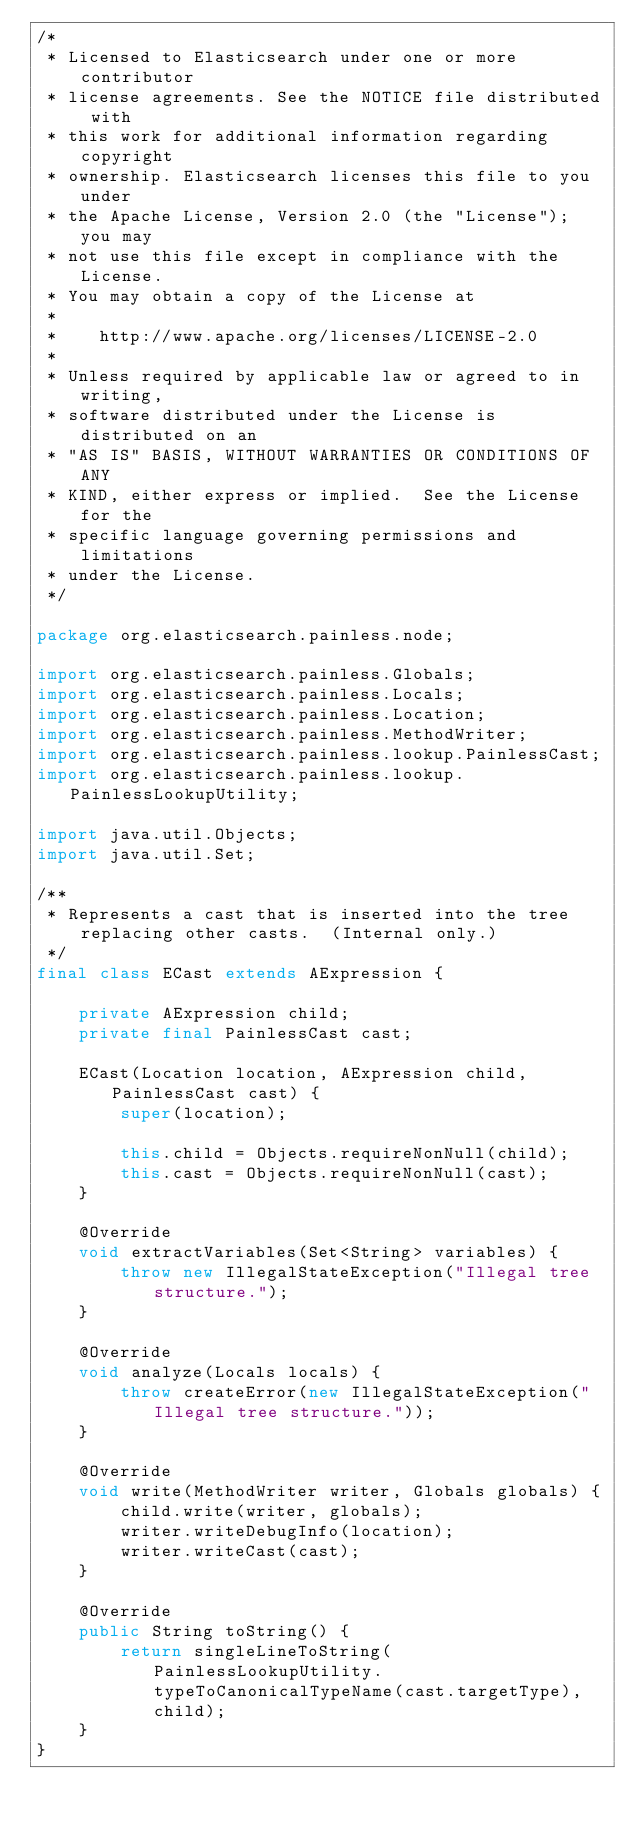Convert code to text. <code><loc_0><loc_0><loc_500><loc_500><_Java_>/*
 * Licensed to Elasticsearch under one or more contributor
 * license agreements. See the NOTICE file distributed with
 * this work for additional information regarding copyright
 * ownership. Elasticsearch licenses this file to you under
 * the Apache License, Version 2.0 (the "License"); you may
 * not use this file except in compliance with the License.
 * You may obtain a copy of the License at
 *
 *    http://www.apache.org/licenses/LICENSE-2.0
 *
 * Unless required by applicable law or agreed to in writing,
 * software distributed under the License is distributed on an
 * "AS IS" BASIS, WITHOUT WARRANTIES OR CONDITIONS OF ANY
 * KIND, either express or implied.  See the License for the
 * specific language governing permissions and limitations
 * under the License.
 */

package org.elasticsearch.painless.node;

import org.elasticsearch.painless.Globals;
import org.elasticsearch.painless.Locals;
import org.elasticsearch.painless.Location;
import org.elasticsearch.painless.MethodWriter;
import org.elasticsearch.painless.lookup.PainlessCast;
import org.elasticsearch.painless.lookup.PainlessLookupUtility;

import java.util.Objects;
import java.util.Set;

/**
 * Represents a cast that is inserted into the tree replacing other casts.  (Internal only.)
 */
final class ECast extends AExpression {

    private AExpression child;
    private final PainlessCast cast;

    ECast(Location location, AExpression child, PainlessCast cast) {
        super(location);

        this.child = Objects.requireNonNull(child);
        this.cast = Objects.requireNonNull(cast);
    }

    @Override
    void extractVariables(Set<String> variables) {
        throw new IllegalStateException("Illegal tree structure.");
    }

    @Override
    void analyze(Locals locals) {
        throw createError(new IllegalStateException("Illegal tree structure."));
    }

    @Override
    void write(MethodWriter writer, Globals globals) {
        child.write(writer, globals);
        writer.writeDebugInfo(location);
        writer.writeCast(cast);
    }

    @Override
    public String toString() {
        return singleLineToString(PainlessLookupUtility.typeToCanonicalTypeName(cast.targetType), child);
    }
}
</code> 